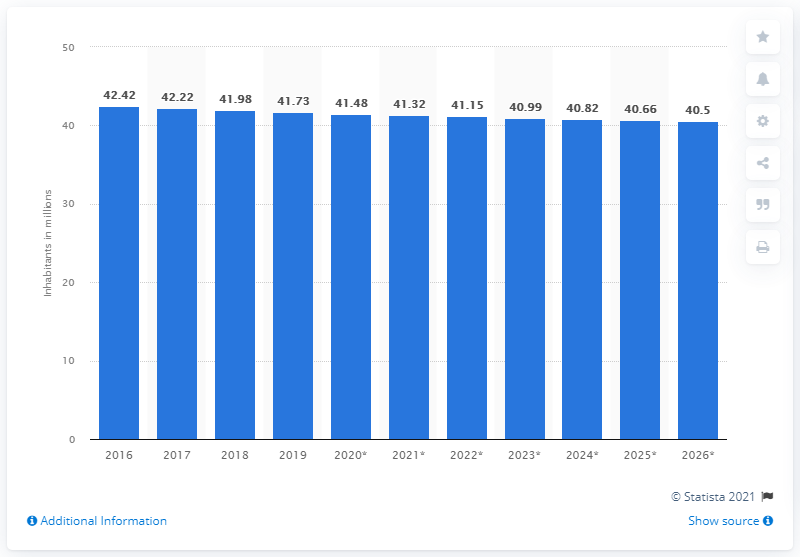Indicate a few pertinent items in this graphic. In 2019, the population of Ukraine was 41.32 million. 